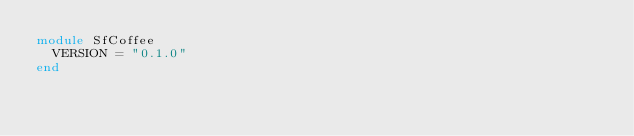Convert code to text. <code><loc_0><loc_0><loc_500><loc_500><_Ruby_>module SfCoffee
  VERSION = "0.1.0"
end
</code> 